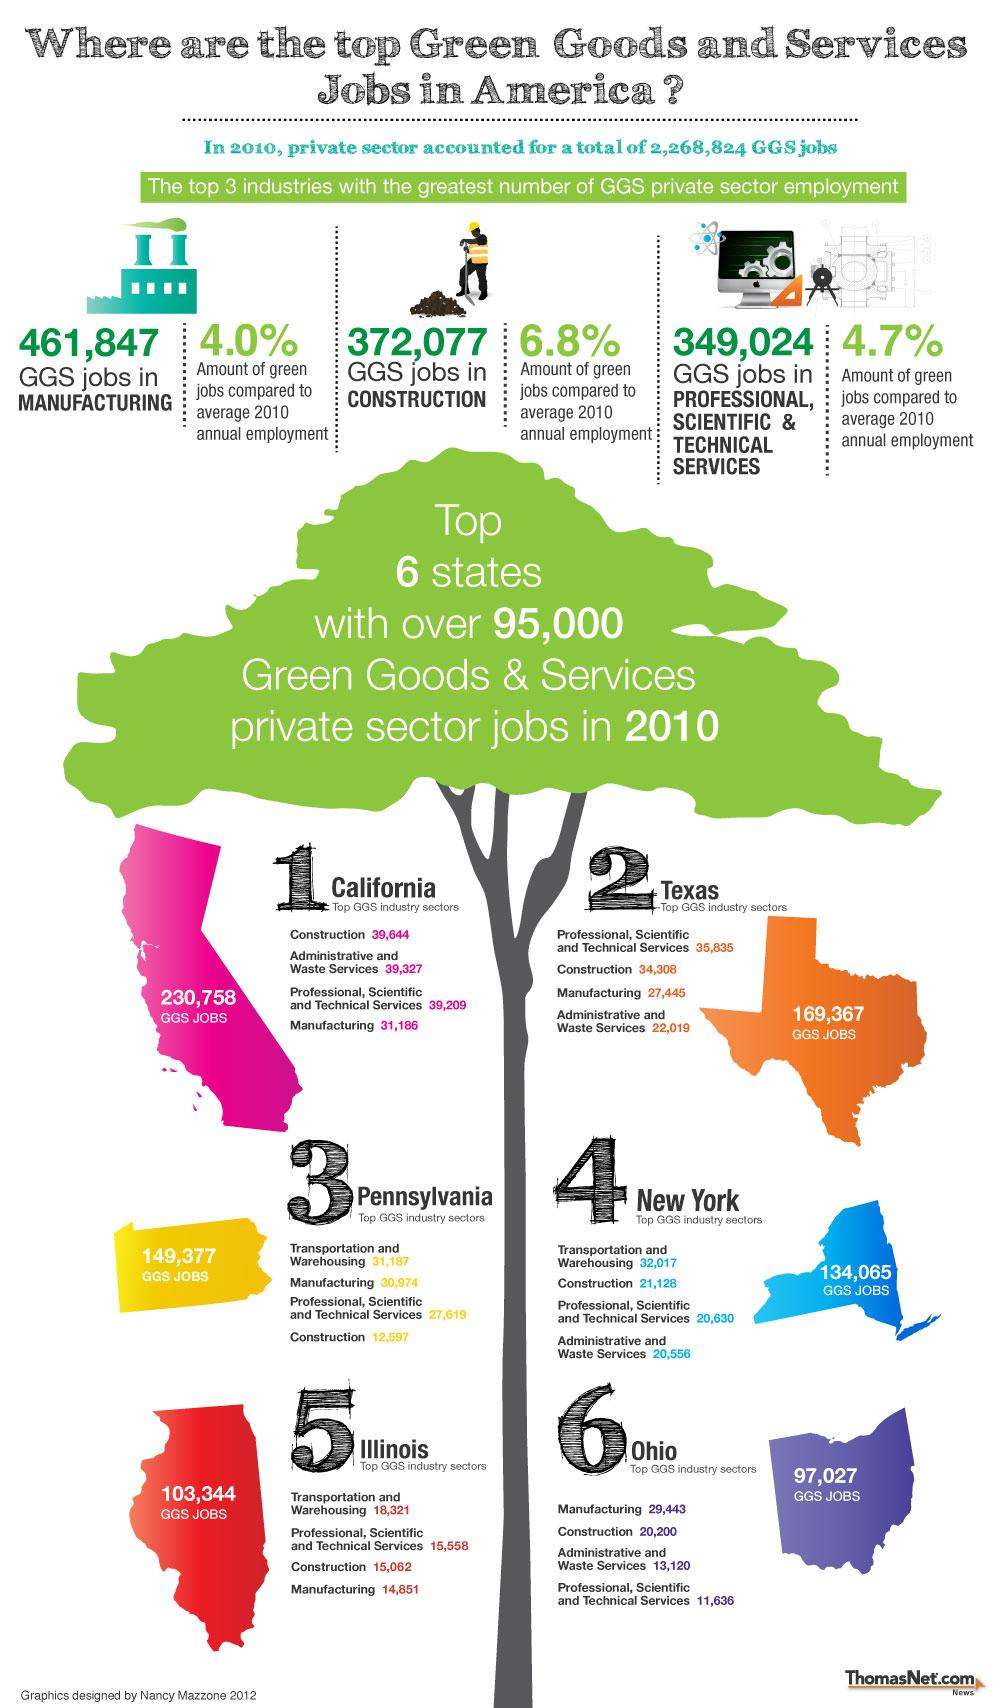Indicate a few pertinent items in this graphic. According to data, there are 169,367 GGS jobs in Texas. New York is the state that is represented in blue color. California has 230,758 GGS jobs. The state with the highest number of jobs categorized as GGS is Illinois, with a total of 103,344 GGS jobs. The total count of transportation and warehousing jobs in Pennsylvania and Illinois is 49,508. 